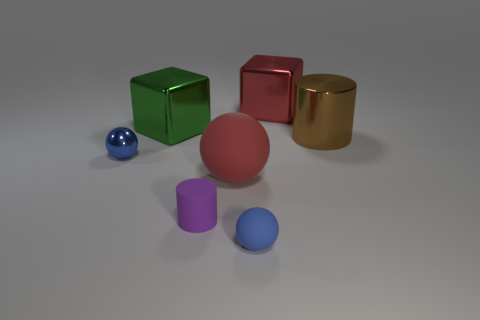What is the brown cylinder made of? Based on the visual cues and the reflective property of the surface, the brown cylinder appears to be made of a polished metal, possibly brass or bronze, which is often used for decorative objects due to its glossy finish and aesthetic appeal. 